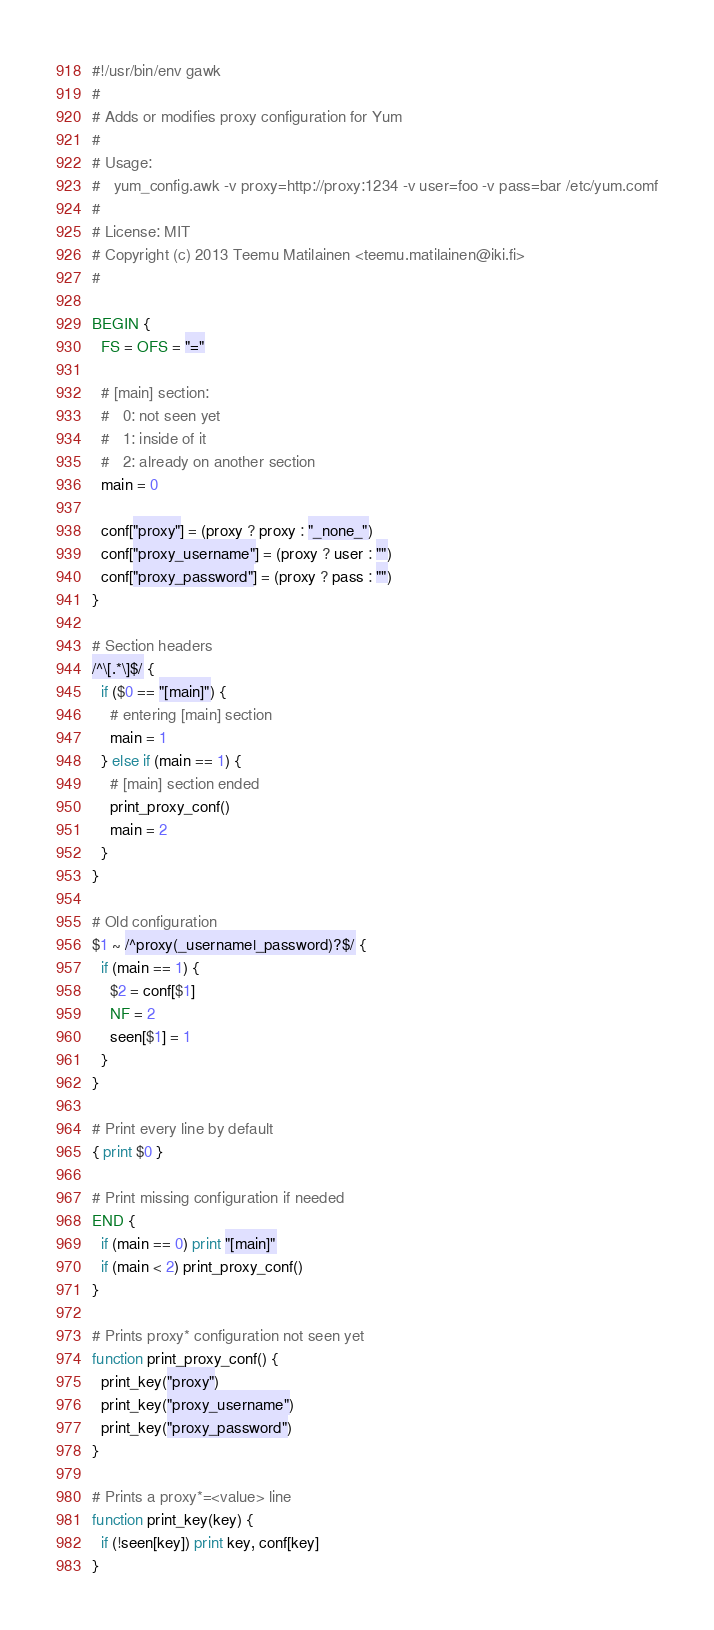Convert code to text. <code><loc_0><loc_0><loc_500><loc_500><_Awk_>#!/usr/bin/env gawk
#
# Adds or modifies proxy configuration for Yum
#
# Usage:
#   yum_config.awk -v proxy=http://proxy:1234 -v user=foo -v pass=bar /etc/yum.comf
#
# License: MIT
# Copyright (c) 2013 Teemu Matilainen <teemu.matilainen@iki.fi>
#

BEGIN {
  FS = OFS = "="

  # [main] section:
  #   0: not seen yet
  #   1: inside of it
  #   2: already on another section
  main = 0

  conf["proxy"] = (proxy ? proxy : "_none_")
  conf["proxy_username"] = (proxy ? user : "")
  conf["proxy_password"] = (proxy ? pass : "")
}

# Section headers
/^\[.*\]$/ {
  if ($0 == "[main]") {
    # entering [main] section
    main = 1
  } else if (main == 1) {
    # [main] section ended
    print_proxy_conf()
    main = 2
  }
}

# Old configuration
$1 ~ /^proxy(_username|_password)?$/ {
  if (main == 1) {
    $2 = conf[$1]
    NF = 2
    seen[$1] = 1
  }
}

# Print every line by default
{ print $0 }

# Print missing configuration if needed
END {
  if (main == 0) print "[main]"
  if (main < 2) print_proxy_conf()
}

# Prints proxy* configuration not seen yet
function print_proxy_conf() {
  print_key("proxy")
  print_key("proxy_username")
  print_key("proxy_password")
}

# Prints a proxy*=<value> line
function print_key(key) {
  if (!seen[key]) print key, conf[key]
}
</code> 